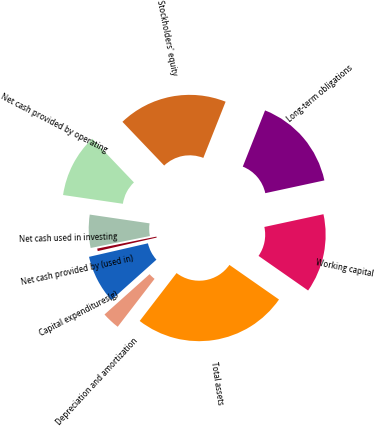<chart> <loc_0><loc_0><loc_500><loc_500><pie_chart><fcel>Net cash provided by operating<fcel>Net cash used in investing<fcel>Net cash provided by (used in)<fcel>Capital expenditures(g)<fcel>Depreciation and amortization<fcel>Total assets<fcel>Working capital<fcel>Long-term obligations<fcel>Stockholders' equity<nl><fcel>10.55%<fcel>5.49%<fcel>0.42%<fcel>8.02%<fcel>2.95%<fcel>25.74%<fcel>13.08%<fcel>15.61%<fcel>18.14%<nl></chart> 